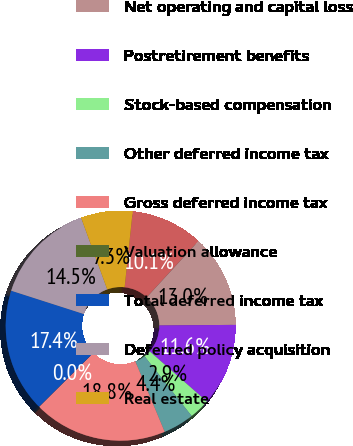Convert chart. <chart><loc_0><loc_0><loc_500><loc_500><pie_chart><fcel>Insurance liabilities<fcel>Net operating and capital loss<fcel>Postretirement benefits<fcel>Stock-based compensation<fcel>Other deferred income tax<fcel>Gross deferred income tax<fcel>Valuation allowance<fcel>Total deferred income tax<fcel>Deferred policy acquisition<fcel>Real estate<nl><fcel>10.14%<fcel>13.04%<fcel>11.59%<fcel>2.91%<fcel>4.35%<fcel>18.83%<fcel>0.01%<fcel>17.38%<fcel>14.49%<fcel>7.25%<nl></chart> 